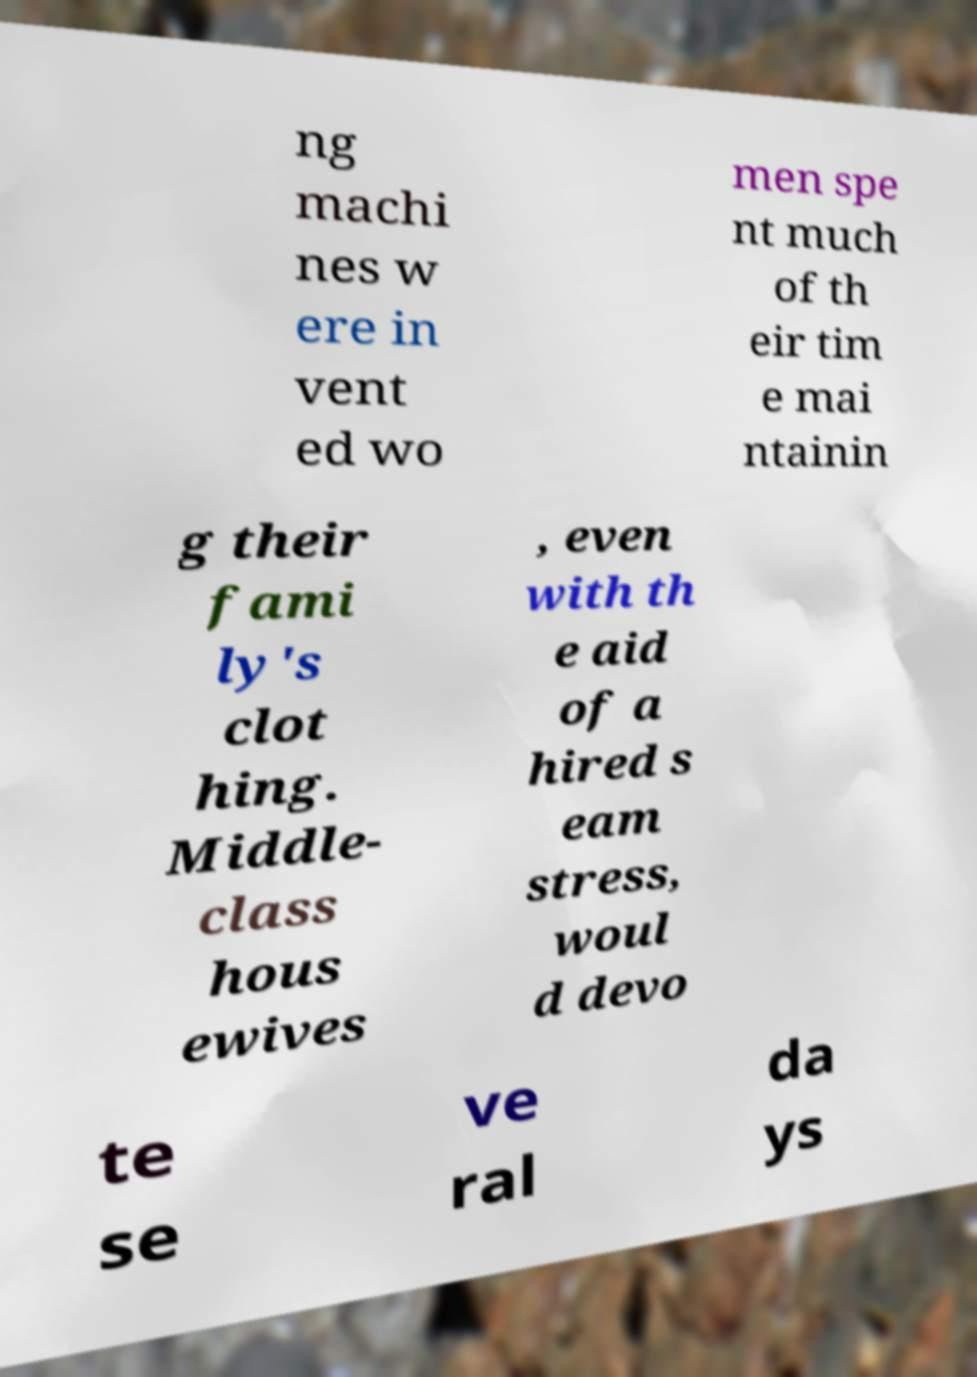What messages or text are displayed in this image? I need them in a readable, typed format. ng machi nes w ere in vent ed wo men spe nt much of th eir tim e mai ntainin g their fami ly's clot hing. Middle- class hous ewives , even with th e aid of a hired s eam stress, woul d devo te se ve ral da ys 